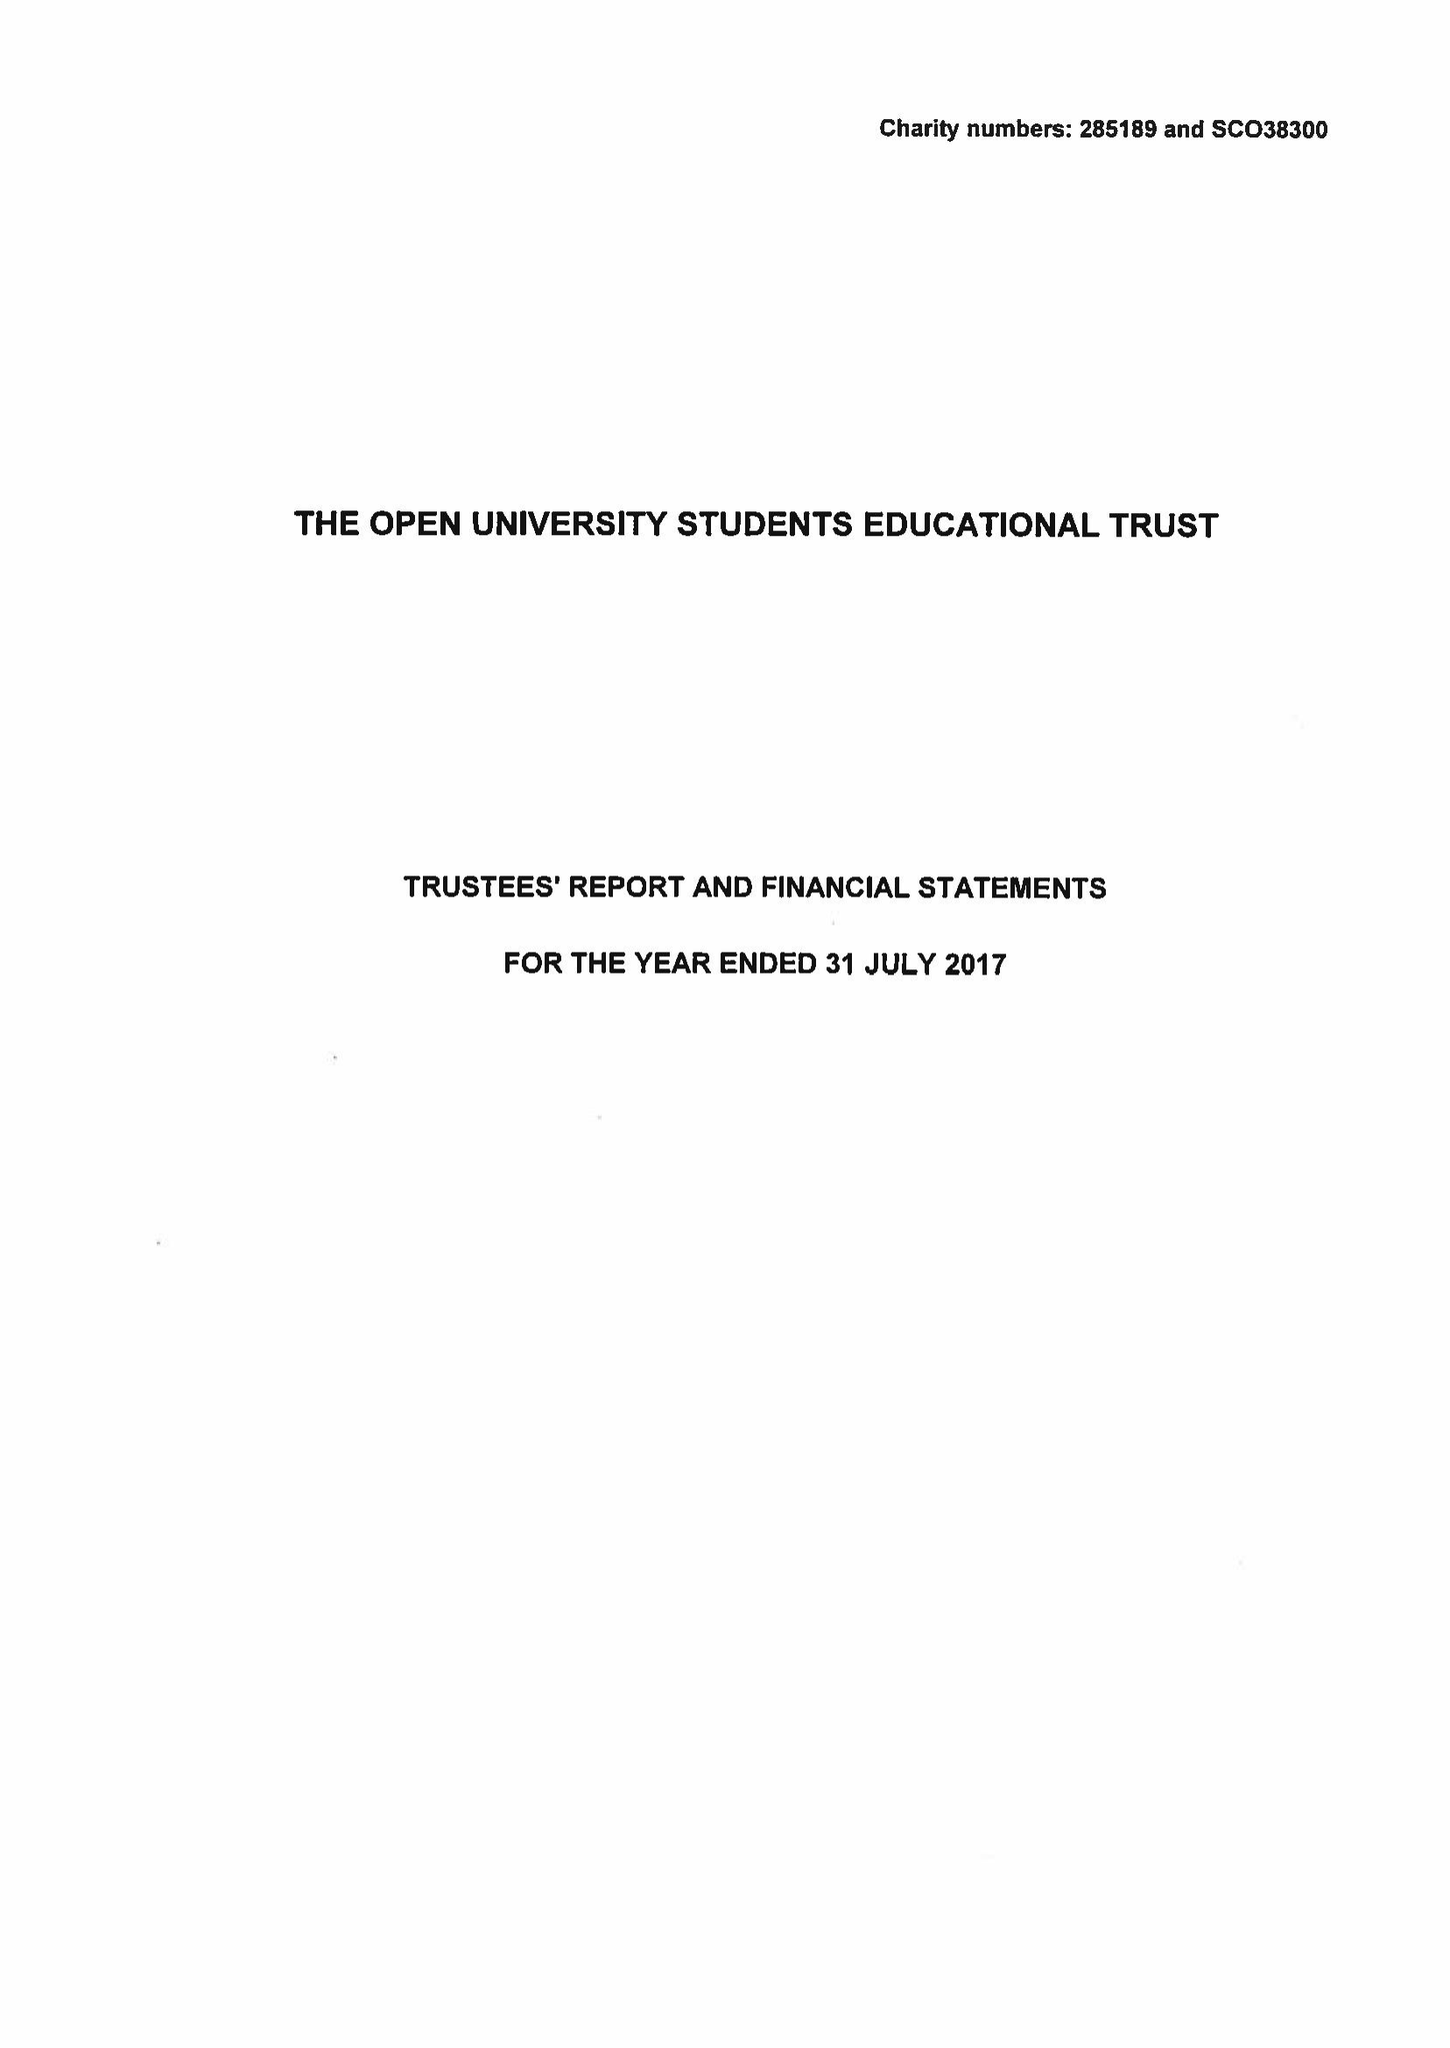What is the value for the charity_number?
Answer the question using a single word or phrase. 285189 